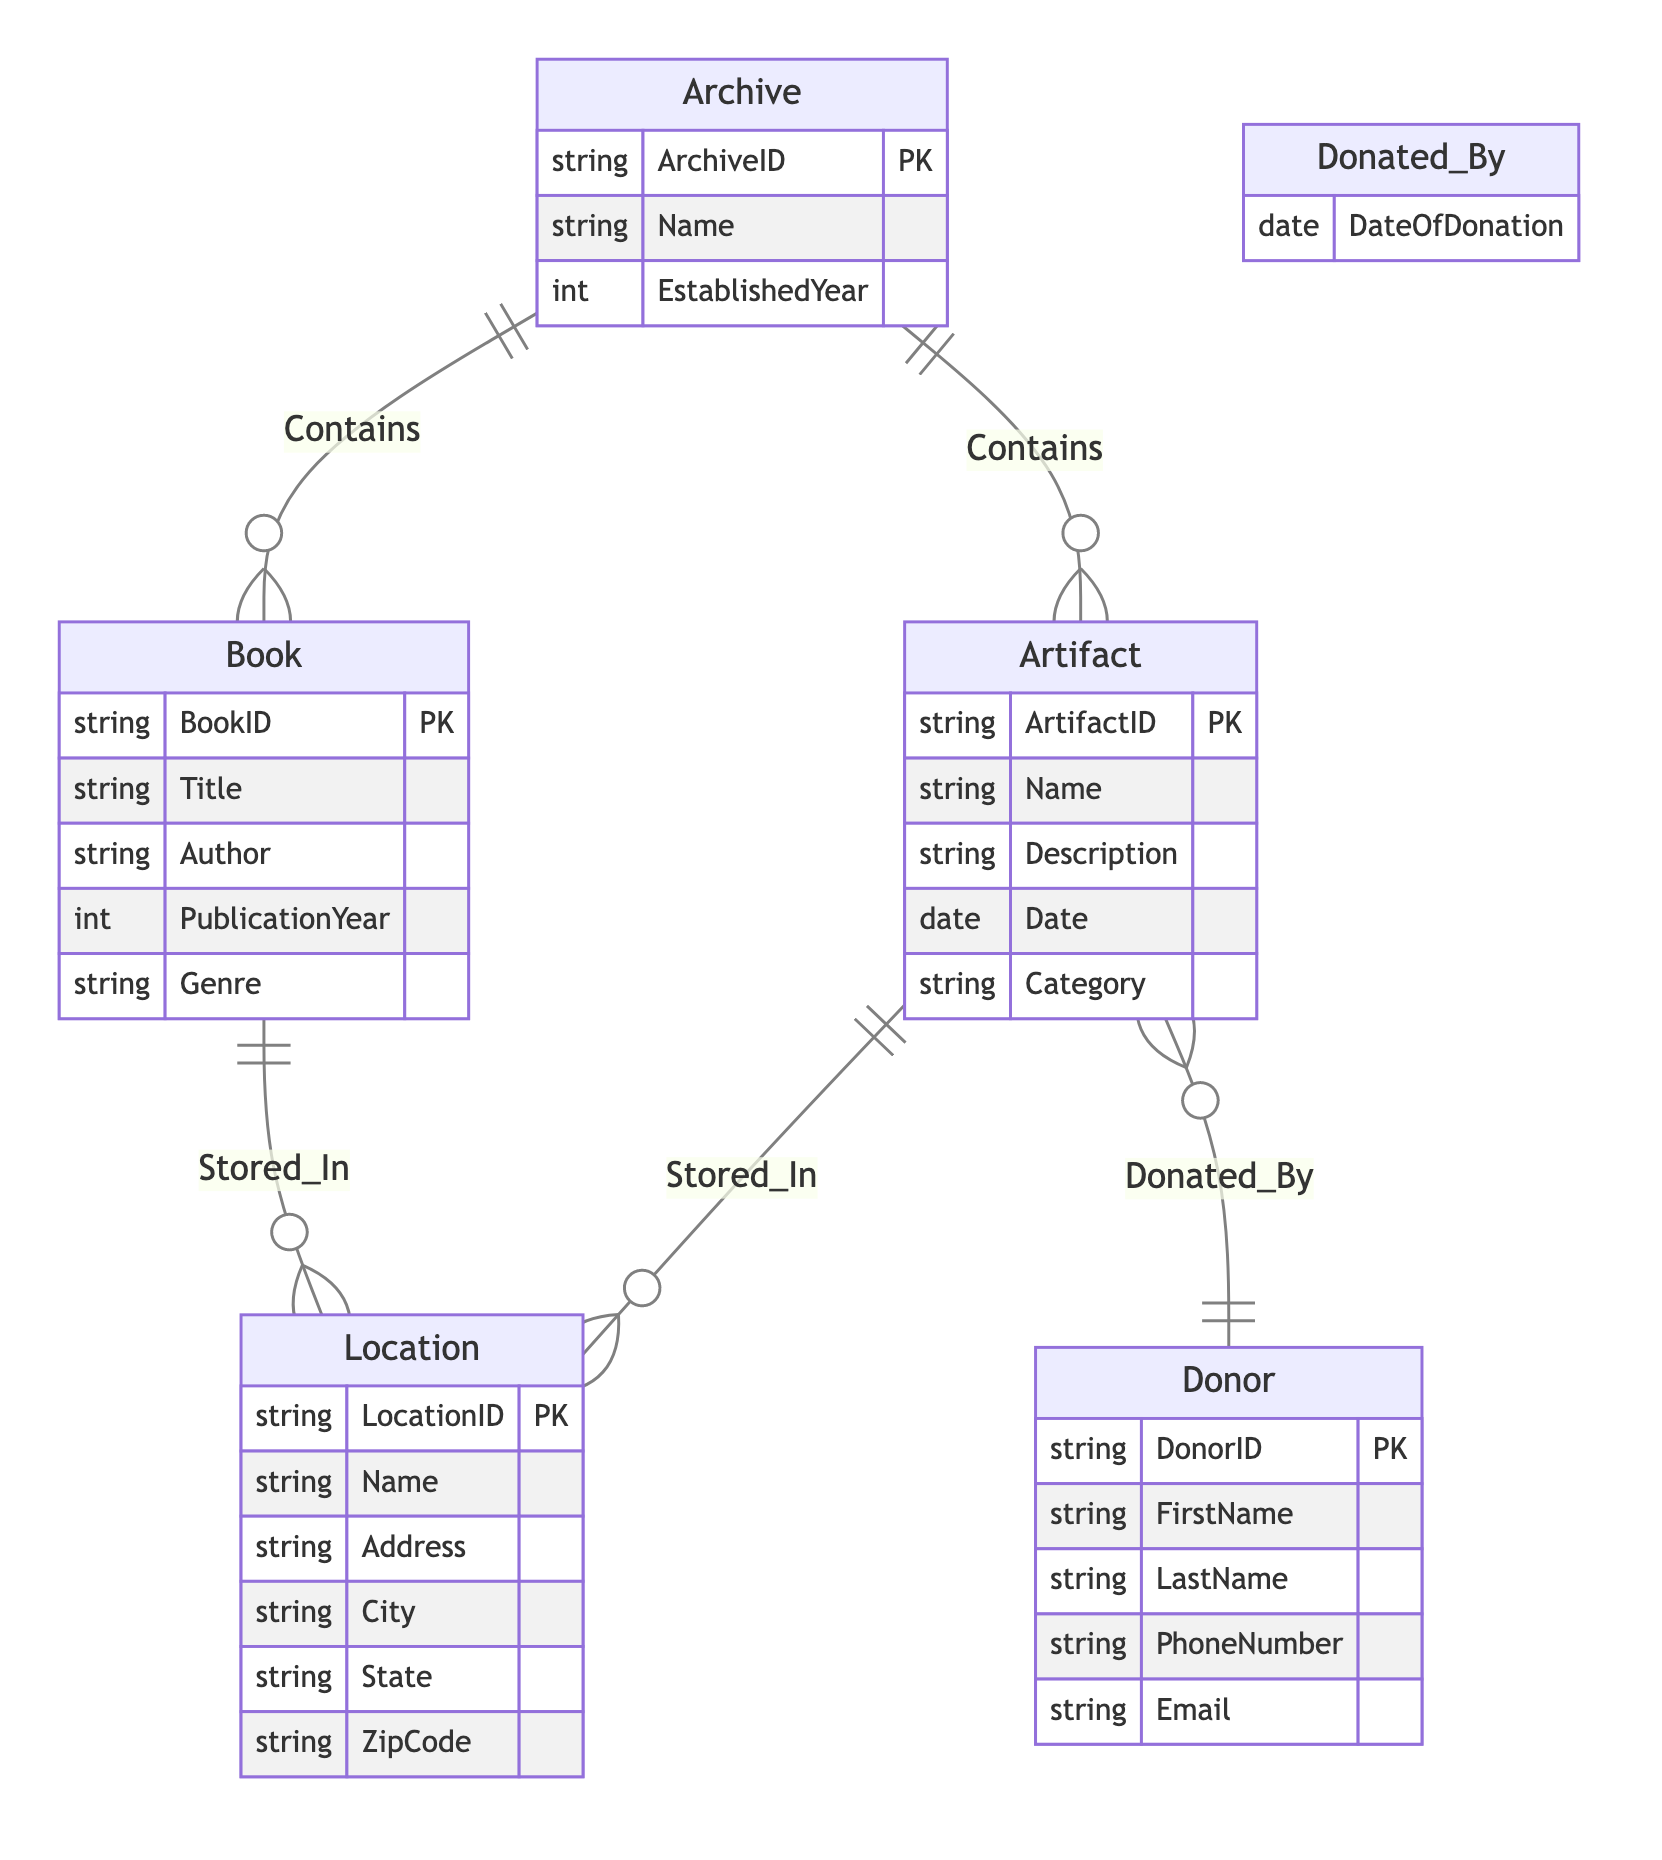What are the entities in the diagram? The diagram includes five entities: Book, Artifact, Location, Donor, and Archive. These can be identified as they represent the main objects involved in the local history archive system.
Answer: Book, Artifact, Location, Donor, Archive How many attributes does the Artifact entity have? The Artifact entity has five attributes: ArtifactID, Name, Description, Date, and Category. This can be seen listed under the Artifact entity in the diagram.
Answer: 5 What relationship exists between Archive and Artifact? The relationship between Archive and Artifact is labeled "Contains", indicating that an Archive can hold multiple Artifacts. This relationship is shown with a connecting line labeled "Contains" in the diagram.
Answer: Contains What is the primary key of the Book entity? The primary key of the Book entity is BookID, which is indicated in the diagram by the notation "PK" next to BookID under the Book entity.
Answer: BookID Which entity is associated with the Donor through the relationship Donated_By? The entity associated with the Donor through the relationship Donated_By is Artifact. This is indicated by the line connecting Donor and Artifact with the label "Donated_By" in the diagram.
Answer: Artifact How many relationships are present in the diagram? The diagram presents a total of five relationships: Stored_In (Book to Location), Contains (Archive to Book), Contains (Archive to Artifact), Donated_By (Artifact to Donor), and Stored_In (Artifact to Location). Each connection between entities counts as a unique relationship.
Answer: 5 What is the foreign key in the Donated_By relationship? The foreign key in the Donated_By relationship is ArtifactID, as it connects the Artifact to the Donor entity. Though not explicitly labeled in the diagram, it is implied that the Donor is linked to the Artifact through this relationship.
Answer: ArtifactID Which entity has the attribute PublicationYear? The entity with the attribute PublicationYear is Book. This attribute is listed directly under the Book entity in the diagram as one of its defining characteristics.
Answer: Book How many locations are there associated with artifacts? The diagram indicates that there is a relationship between Artifact and Location, labeled "Stored_In". Since there is one line connecting each batch of entities, it suggests that an Artifact can be stored in various locations. However, the exact number of locations isn't provided, meaning that it is dependent on the actual data rather than the diagram itself.
Answer: Not specified 